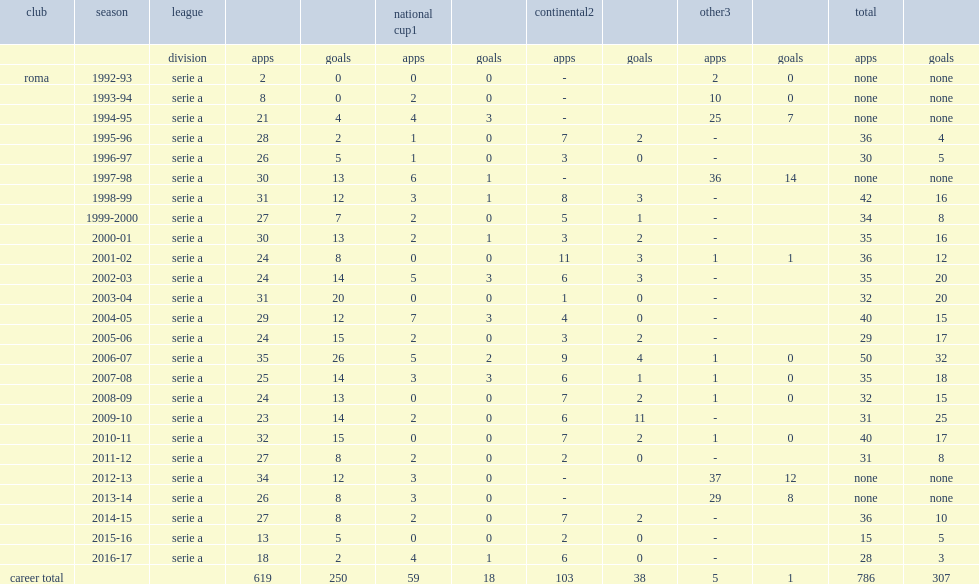How many league goals did totti score for roma in 2010-11? 15.0. 